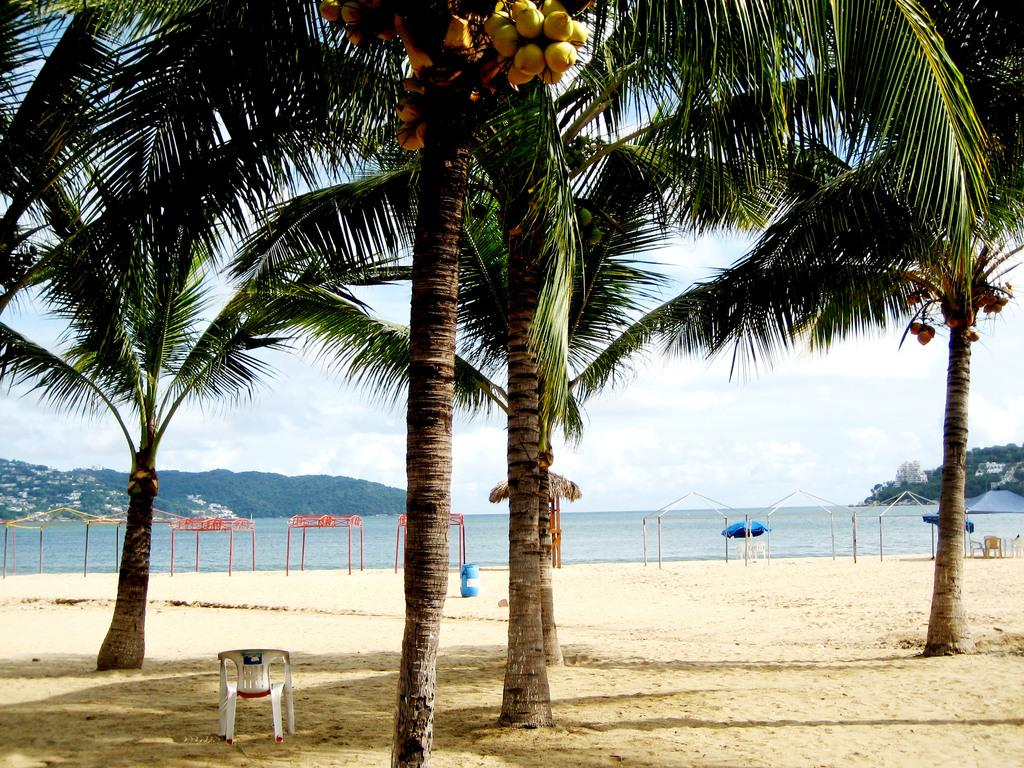What type of vegetation can be seen in the image? There are trees in the image. What type of seating is present in the image? There are chairs in the image. What type of terrain is visible in the image? There is sand in the image. What type of storage or shelter is present in the image? There are sheds in the image. What type of container is present in the image? There is a barrel in the image. What type of shade provider is present in the image? There is an umbrella in the image. What type of fruit is present in the image? There are coconuts in the image. What can be seen in the background of the image? The sky, water, and hills are visible in the background of the image. How does the credit card help in the image? There is no credit card present in the image, so it cannot help in any way. What type of kite is flying in the image? There is no kite present in the image, so it cannot be flying. 